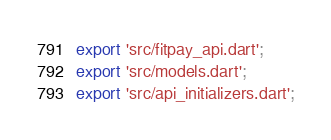<code> <loc_0><loc_0><loc_500><loc_500><_Dart_>export 'src/fitpay_api.dart';
export 'src/models.dart';
export 'src/api_initializers.dart';
</code> 